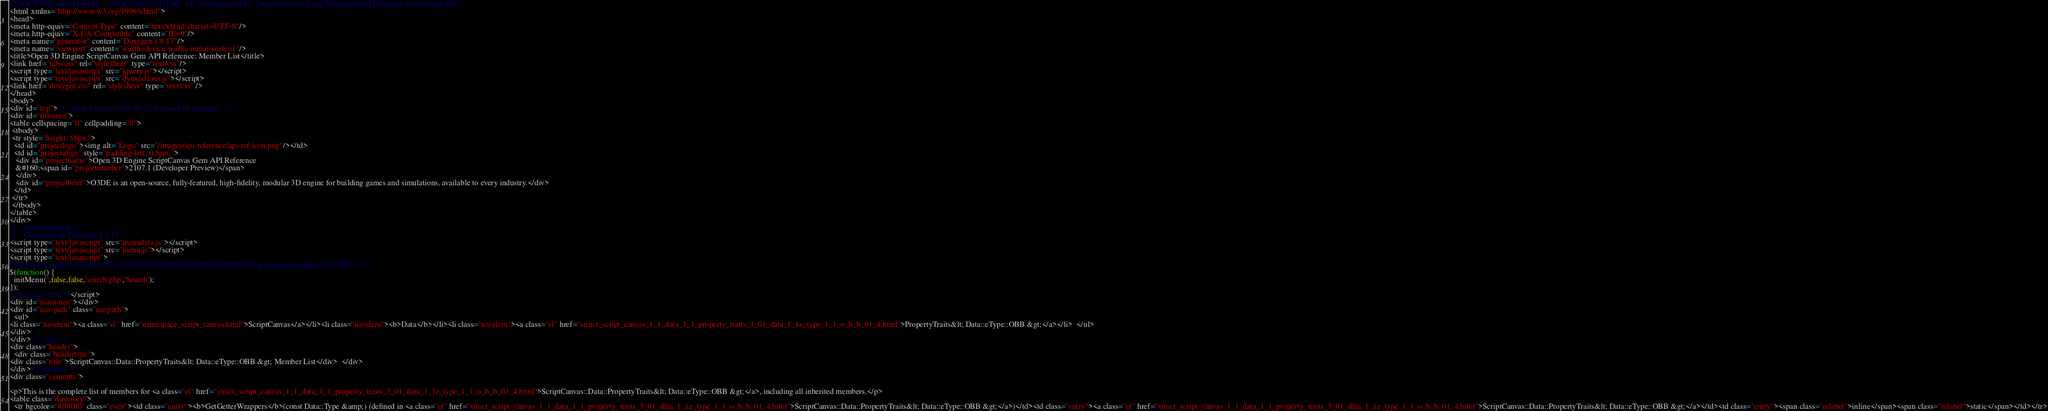Convert code to text. <code><loc_0><loc_0><loc_500><loc_500><_HTML_><!DOCTYPE html PUBLIC "-//W3C//DTD XHTML 1.0 Transitional//EN" "https://www.w3.org/TR/xhtml1/DTD/xhtml1-transitional.dtd">
<html xmlns="http://www.w3.org/1999/xhtml">
<head>
<meta http-equiv="Content-Type" content="text/xhtml;charset=UTF-8"/>
<meta http-equiv="X-UA-Compatible" content="IE=9"/>
<meta name="generator" content="Doxygen 1.8.17"/>
<meta name="viewport" content="width=device-width, initial-scale=1"/>
<title>Open 3D Engine ScriptCanvas Gem API Reference: Member List</title>
<link href="tabs.css" rel="stylesheet" type="text/css"/>
<script type="text/javascript" src="jquery.js"></script>
<script type="text/javascript" src="dynsections.js"></script>
<link href="doxygen.css" rel="stylesheet" type="text/css" />
</head>
<body>
<div id="top"><!-- do not remove this div, it is closed by doxygen! -->
<div id="titlearea">
<table cellspacing="0" cellpadding="0">
 <tbody>
 <tr style="height: 56px;">
  <td id="projectlogo"><img alt="Logo" src="/images/api-reference/api-ref-icon.png"/></td>
  <td id="projectalign" style="padding-left: 0.5em;">
   <div id="projectname">Open 3D Engine ScriptCanvas Gem API Reference
   &#160;<span id="projectnumber">2107.1 (Developer Preview)</span>
   </div>
   <div id="projectbrief">O3DE is an open-source, fully-featured, high-fidelity, modular 3D engine for building games and simulations, available to every industry.</div>
  </td>
 </tr>
 </tbody>
</table>
</div>
<!-- end header part -->
<!-- Generated by Doxygen 1.8.17 -->
<script type="text/javascript" src="menudata.js"></script>
<script type="text/javascript" src="menu.js"></script>
<script type="text/javascript">
/* @license magnet:?xt=urn:btih:cf05388f2679ee054f2beb29a391d25f4e673ac3&amp;dn=gpl-2.0.txt GPL-v2 */
$(function() {
  initMenu('',false,false,'search.php','Search');
});
/* @license-end */</script>
<div id="main-nav"></div>
<div id="nav-path" class="navpath">
  <ul>
<li class="navelem"><a class="el" href="namespace_script_canvas.html">ScriptCanvas</a></li><li class="navelem"><b>Data</b></li><li class="navelem"><a class="el" href="struct_script_canvas_1_1_data_1_1_property_traits_3_01_data_1_1e_type_1_1_o_b_b_01_4.html">PropertyTraits&lt; Data::eType::OBB &gt;</a></li>  </ul>
</div>
</div><!-- top -->
<div class="header">
  <div class="headertitle">
<div class="title">ScriptCanvas::Data::PropertyTraits&lt; Data::eType::OBB &gt; Member List</div>  </div>
</div><!--header-->
<div class="contents">

<p>This is the complete list of members for <a class="el" href="struct_script_canvas_1_1_data_1_1_property_traits_3_01_data_1_1e_type_1_1_o_b_b_01_4.html">ScriptCanvas::Data::PropertyTraits&lt; Data::eType::OBB &gt;</a>, including all inherited members.</p>
<table class="directory">
  <tr bgcolor="#f0f0f0" class="even"><td class="entry"><b>GetGetterWrappers</b>(const Data::Type &amp;) (defined in <a class="el" href="struct_script_canvas_1_1_data_1_1_property_traits_3_01_data_1_1e_type_1_1_o_b_b_01_4.html">ScriptCanvas::Data::PropertyTraits&lt; Data::eType::OBB &gt;</a>)</td><td class="entry"><a class="el" href="struct_script_canvas_1_1_data_1_1_property_traits_3_01_data_1_1e_type_1_1_o_b_b_01_4.html">ScriptCanvas::Data::PropertyTraits&lt; Data::eType::OBB &gt;</a></td><td class="entry"><span class="mlabel">inline</span><span class="mlabel">static</span></td></tr></code> 